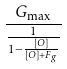Convert formula to latex. <formula><loc_0><loc_0><loc_500><loc_500>\frac { G _ { \max } } { \frac { 1 } { 1 - \frac { [ O ] } { [ O ] + F _ { g } } } }</formula> 